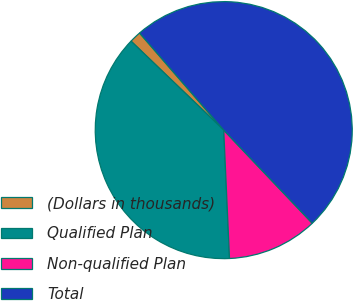Convert chart. <chart><loc_0><loc_0><loc_500><loc_500><pie_chart><fcel>(Dollars in thousands)<fcel>Qualified Plan<fcel>Non-qualified Plan<fcel>Total<nl><fcel>1.46%<fcel>37.89%<fcel>11.38%<fcel>49.27%<nl></chart> 